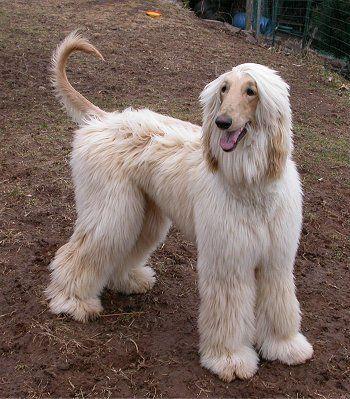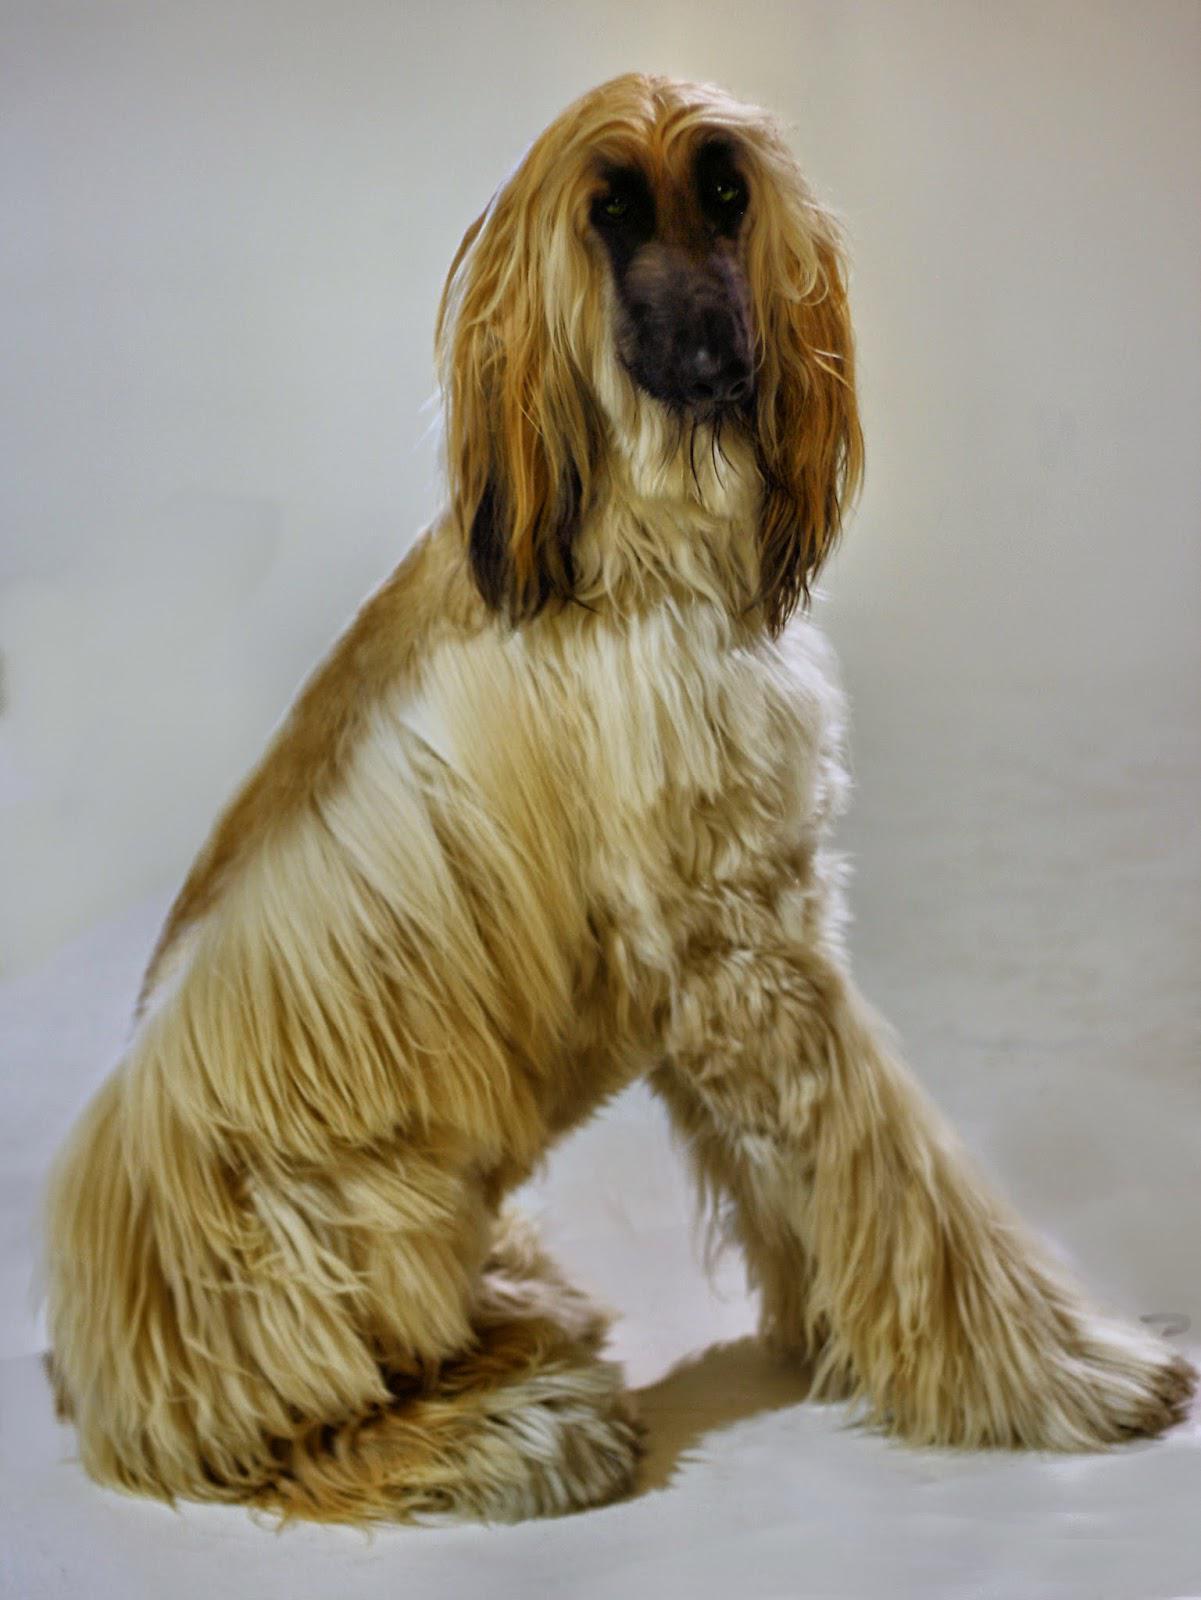The first image is the image on the left, the second image is the image on the right. For the images displayed, is the sentence "Each image contains a single afghan hound, no hound is primarily black, and the hound on the left has its curled orange tail visible." factually correct? Answer yes or no. Yes. 